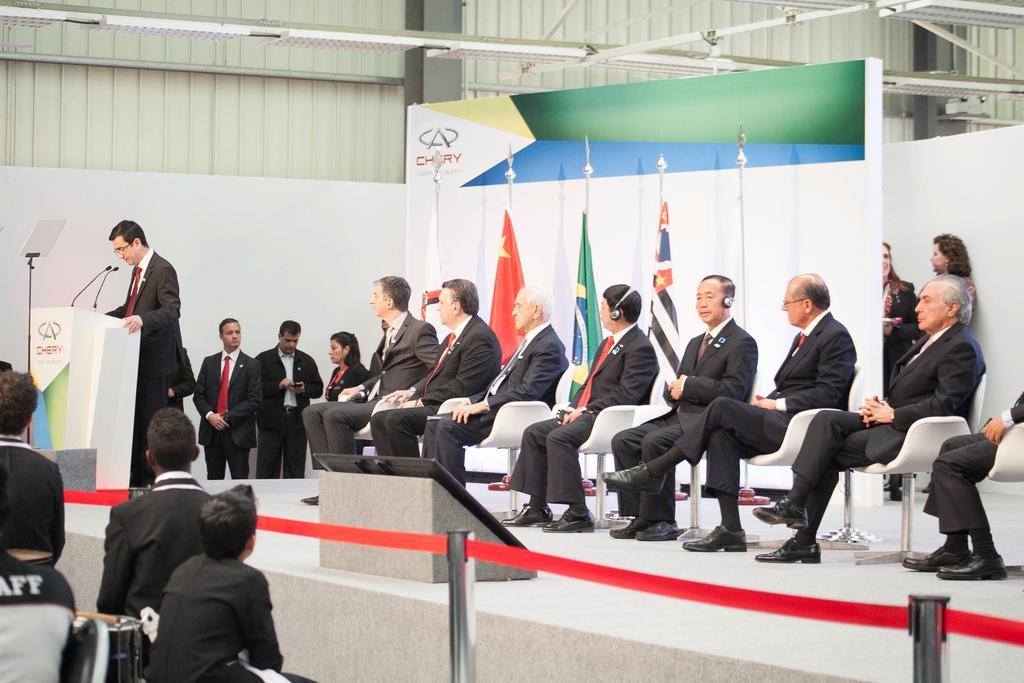In one or two sentences, can you explain what this image depicts? In this picture I can see group of people sitting on the chairs, there are group of people standing, there is a man standing near the podium, there are mikes on the podium, there are stanchion barriers, flags and there is a board. 